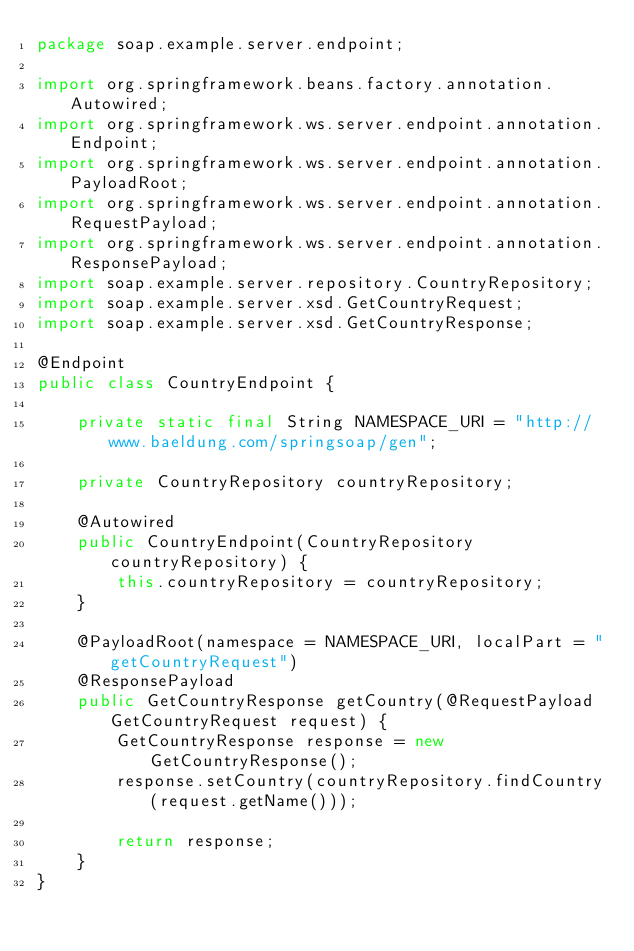Convert code to text. <code><loc_0><loc_0><loc_500><loc_500><_Java_>package soap.example.server.endpoint;

import org.springframework.beans.factory.annotation.Autowired;
import org.springframework.ws.server.endpoint.annotation.Endpoint;
import org.springframework.ws.server.endpoint.annotation.PayloadRoot;
import org.springframework.ws.server.endpoint.annotation.RequestPayload;
import org.springframework.ws.server.endpoint.annotation.ResponsePayload;
import soap.example.server.repository.CountryRepository;
import soap.example.server.xsd.GetCountryRequest;
import soap.example.server.xsd.GetCountryResponse;

@Endpoint
public class CountryEndpoint {

    private static final String NAMESPACE_URI = "http://www.baeldung.com/springsoap/gen";

    private CountryRepository countryRepository;

    @Autowired
    public CountryEndpoint(CountryRepository countryRepository) {
        this.countryRepository = countryRepository;
    }

    @PayloadRoot(namespace = NAMESPACE_URI, localPart = "getCountryRequest")
    @ResponsePayload
    public GetCountryResponse getCountry(@RequestPayload GetCountryRequest request) {
        GetCountryResponse response = new GetCountryResponse();
        response.setCountry(countryRepository.findCountry(request.getName()));

        return response;
    }
}</code> 